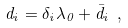<formula> <loc_0><loc_0><loc_500><loc_500>d _ { i } = \delta _ { i } \lambda _ { 0 } + \bar { d } _ { i } \ ,</formula> 